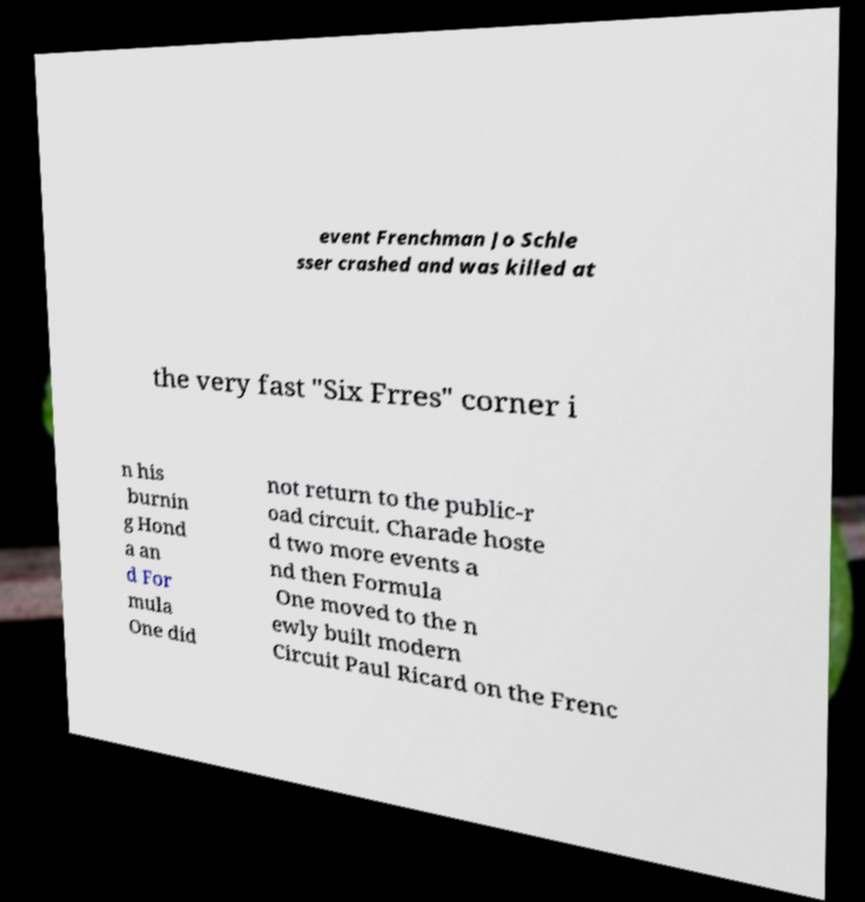Please read and relay the text visible in this image. What does it say? event Frenchman Jo Schle sser crashed and was killed at the very fast "Six Frres" corner i n his burnin g Hond a an d For mula One did not return to the public-r oad circuit. Charade hoste d two more events a nd then Formula One moved to the n ewly built modern Circuit Paul Ricard on the Frenc 